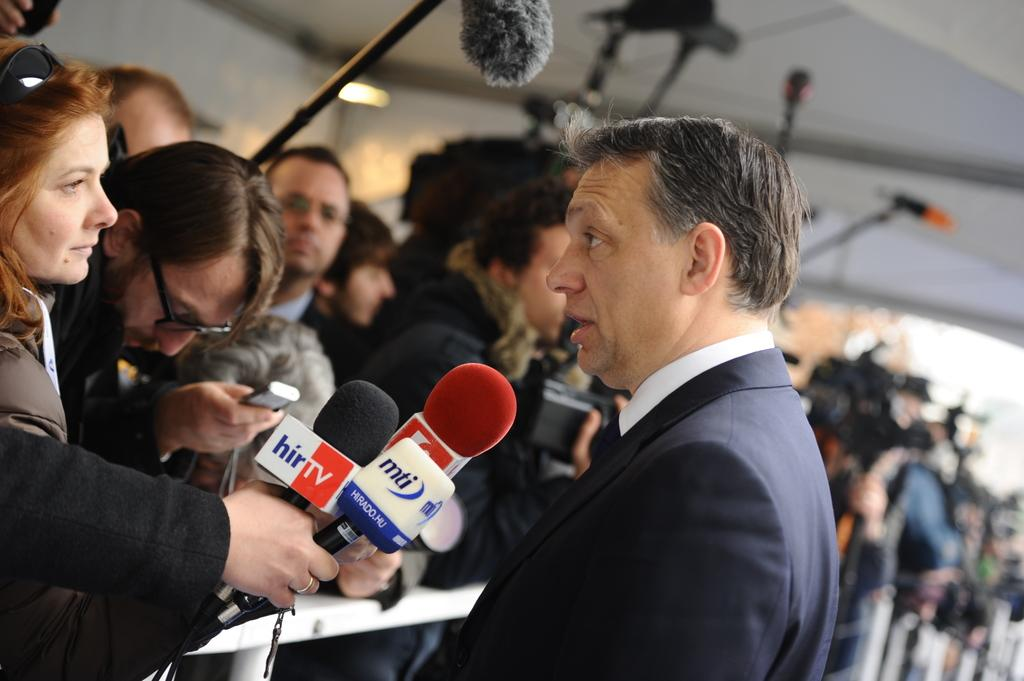What is the man in the image doing? The man is speaking in the image. What are the other people in the image doing? Some of the people are holding microphones, while others are holding cameras in their hands. How many people are holding microphones in the image? The fact does not specify the exact number, but it mentions that some people are holding microphones. What type of fruit is being used as a brake in the image? There is no fruit or brake present in the image. What type of hall is visible in the image? The fact does not mention any hall in the image. 